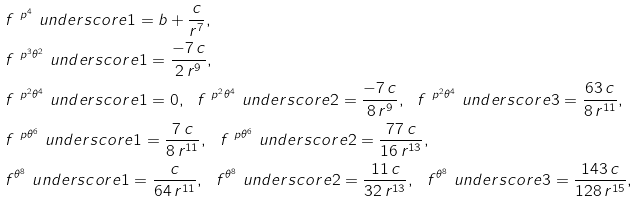<formula> <loc_0><loc_0><loc_500><loc_500>& f ^ { { \ p } ^ { 4 } } \ u n d e r s c o r e 1 = b + \frac { c } { r ^ { 7 } } , \\ & f ^ { { \ p } ^ { 3 } { \theta } ^ { 2 } } \ u n d e r s c o r e 1 = \frac { - 7 \, c } { 2 \, r ^ { 9 } } , \\ & f ^ { { \ p } ^ { 2 } { \theta } ^ { 4 } } \ u n d e r s c o r e 1 = 0 , \ \ f ^ { { \ p } ^ { 2 } { \theta } ^ { 4 } } \ u n d e r s c o r e 2 = \frac { - 7 \, c } { 8 \, r ^ { 9 } } , \ \ f ^ { { \ p } ^ { 2 } { \theta } ^ { 4 } } \ u n d e r s c o r e 3 = \frac { 6 3 \, c } { 8 \, r ^ { 1 1 } } , \\ & f ^ { \ p { \theta } ^ { 6 } } \ u n d e r s c o r e 1 = \frac { 7 \, c } { 8 \, r ^ { 1 1 } } , \ \ f ^ { \ p { \theta } ^ { 6 } } \ u n d e r s c o r e 2 = \frac { 7 7 \, c } { 1 6 \, r ^ { 1 3 } } , \\ & f ^ { { \theta } ^ { 8 } } \ u n d e r s c o r e 1 = \frac { c } { 6 4 \, r ^ { 1 1 } } , \ \ f ^ { { \theta } ^ { 8 } } \ u n d e r s c o r e 2 = \frac { 1 1 \, c } { 3 2 \, r ^ { 1 3 } } , \ \ f ^ { { \theta } ^ { 8 } } \ u n d e r s c o r e 3 = \frac { 1 4 3 \, c } { 1 2 8 \, r ^ { 1 5 } } ,</formula> 